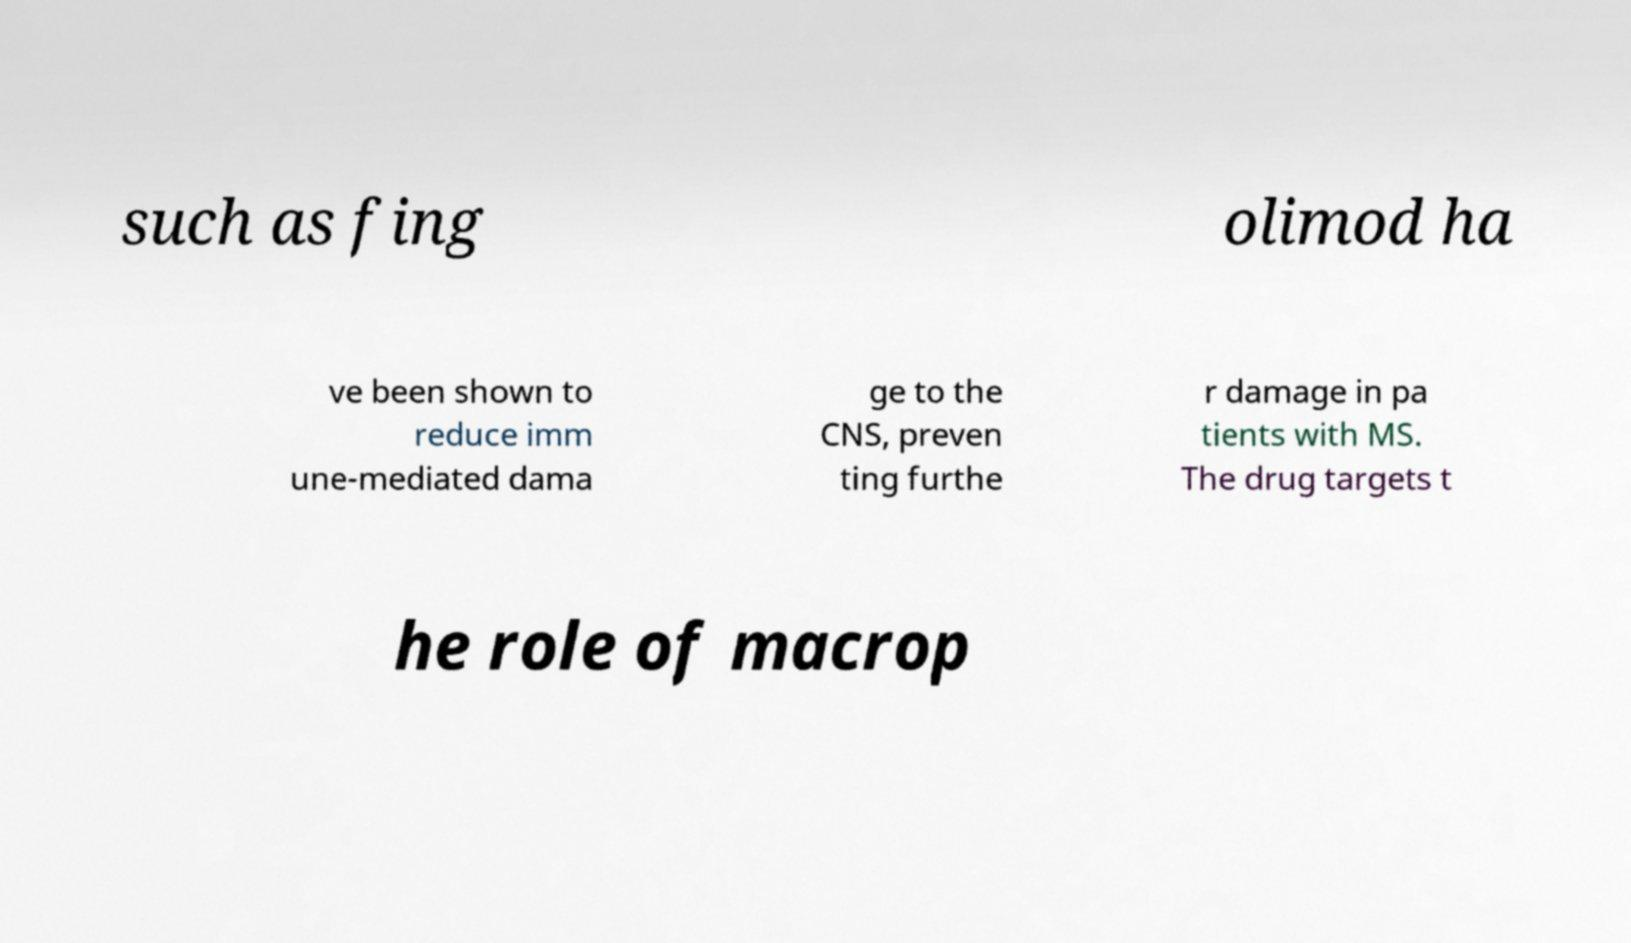For documentation purposes, I need the text within this image transcribed. Could you provide that? such as fing olimod ha ve been shown to reduce imm une-mediated dama ge to the CNS, preven ting furthe r damage in pa tients with MS. The drug targets t he role of macrop 